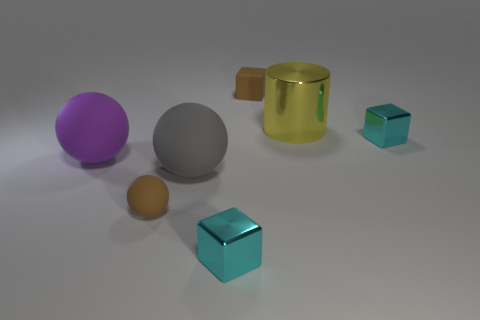There is a tiny cube that is the same color as the small sphere; what is its material?
Offer a terse response. Rubber. There is a brown thing that is the same shape as the purple thing; what is its material?
Offer a very short reply. Rubber. Are there any other things that are the same material as the brown ball?
Offer a terse response. Yes. What number of other things are there of the same shape as the big gray thing?
Your answer should be compact. 2. How many tiny rubber things are left of the large matte object on the right side of the matte ball in front of the big gray matte thing?
Your answer should be very brief. 1. What number of brown objects are the same shape as the gray object?
Provide a succinct answer. 1. Does the large matte object that is to the right of the purple rubber ball have the same color as the metallic cylinder?
Make the answer very short. No. What shape is the tiny brown object in front of the tiny cyan metal block behind the cyan metal thing that is in front of the brown rubber ball?
Offer a terse response. Sphere. There is a gray object; is it the same size as the brown object that is behind the large purple object?
Make the answer very short. No. Is there a thing that has the same size as the cylinder?
Ensure brevity in your answer.  Yes. 